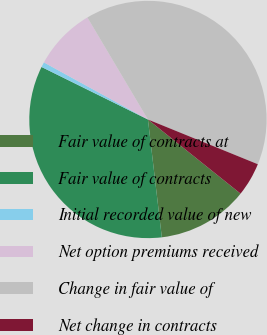<chart> <loc_0><loc_0><loc_500><loc_500><pie_chart><fcel>Fair value of contracts at<fcel>Fair value of contracts<fcel>Initial recorded value of new<fcel>Net option premiums received<fcel>Change in fair value of<fcel>Net change in contracts<nl><fcel>12.39%<fcel>34.17%<fcel>0.69%<fcel>8.49%<fcel>39.68%<fcel>4.59%<nl></chart> 